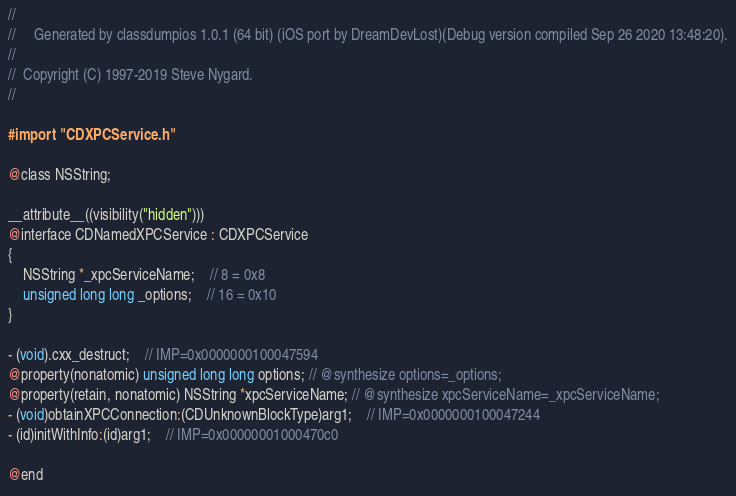Convert code to text. <code><loc_0><loc_0><loc_500><loc_500><_C_>//
//     Generated by classdumpios 1.0.1 (64 bit) (iOS port by DreamDevLost)(Debug version compiled Sep 26 2020 13:48:20).
//
//  Copyright (C) 1997-2019 Steve Nygard.
//

#import "CDXPCService.h"

@class NSString;

__attribute__((visibility("hidden")))
@interface CDNamedXPCService : CDXPCService
{
    NSString *_xpcServiceName;	// 8 = 0x8
    unsigned long long _options;	// 16 = 0x10
}

- (void).cxx_destruct;	// IMP=0x0000000100047594
@property(nonatomic) unsigned long long options; // @synthesize options=_options;
@property(retain, nonatomic) NSString *xpcServiceName; // @synthesize xpcServiceName=_xpcServiceName;
- (void)obtainXPCConnection:(CDUnknownBlockType)arg1;	// IMP=0x0000000100047244
- (id)initWithInfo:(id)arg1;	// IMP=0x00000001000470c0

@end

</code> 